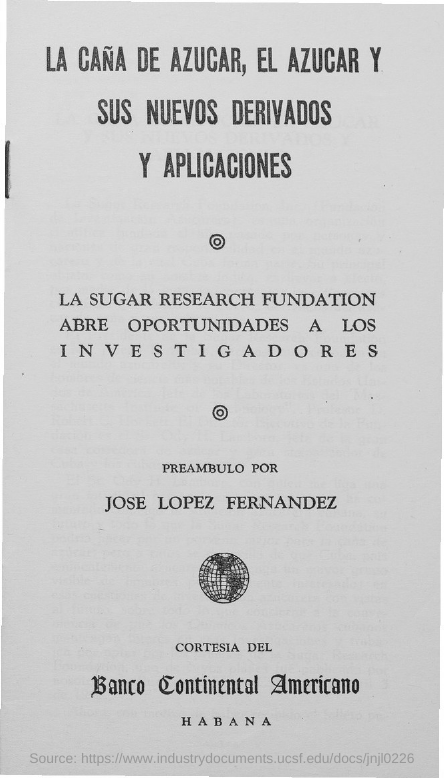What is the name of the person mentioned in the document?
Your response must be concise. Jose lopez fernandez. 